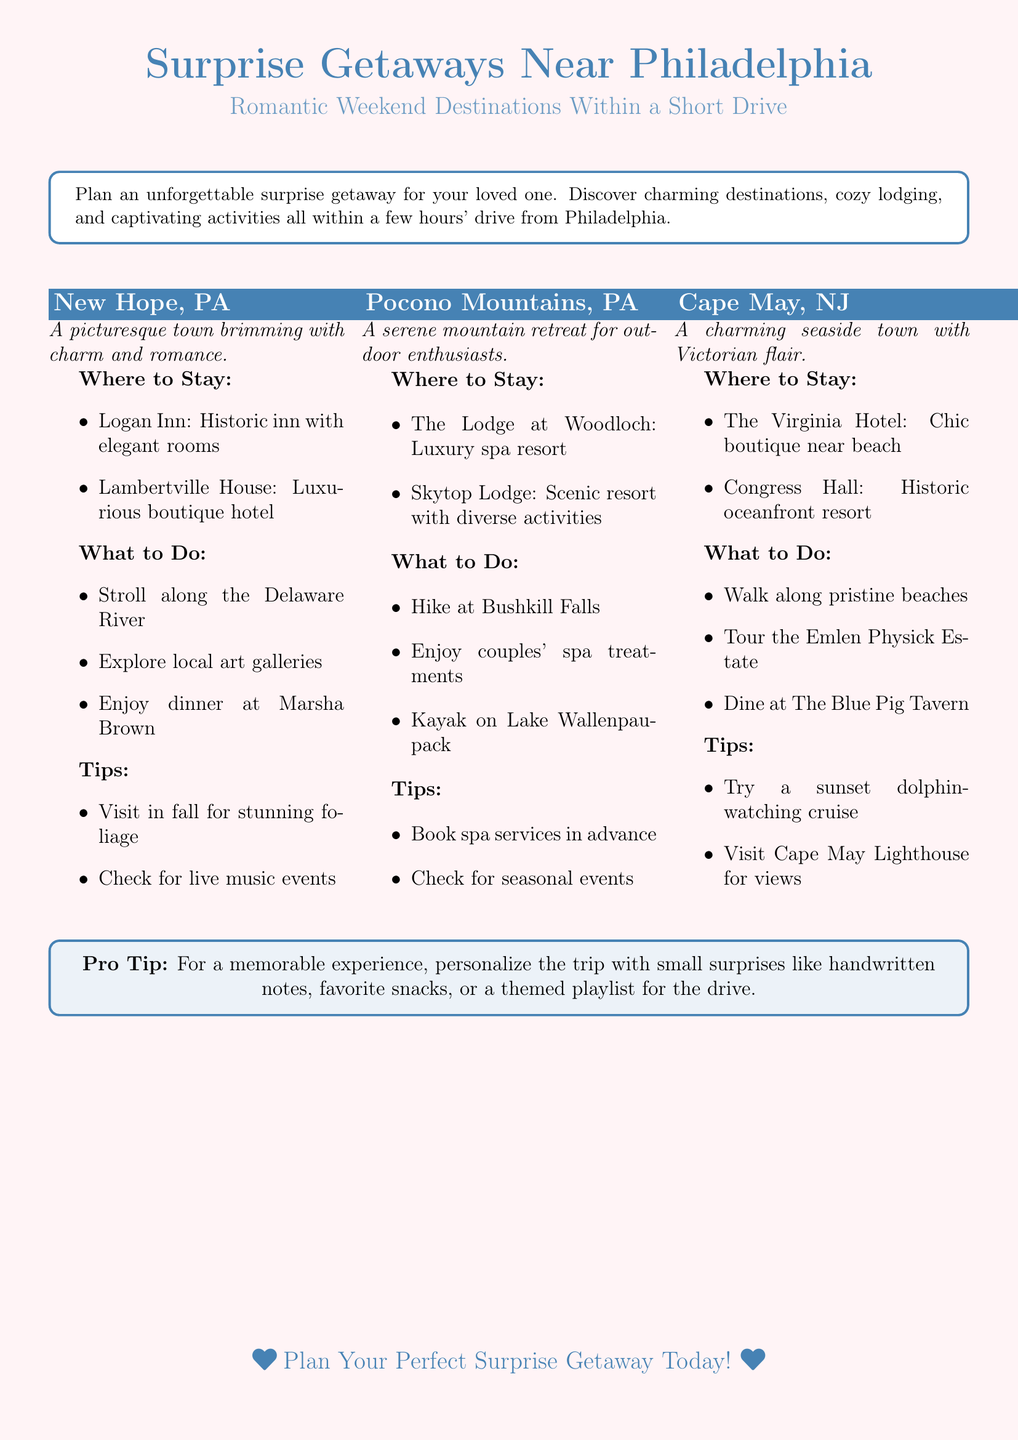What is the title of the flyer? The title is prominently displayed at the top of the document and states the main theme of the flyer.
Answer: Surprise Getaways Near Philadelphia How many getaway destinations are mentioned in the flyer? The flyer lists three specific getaway destinations, making it easy to plan a trip.
Answer: 3 What is one activity to do in New Hope, PA? The flyer lists several activities for each location, specifying what can be enjoyed at the respective destination.
Answer: Stroll along the Delaware River What is the recommended lodging in Cape May, NJ? Each getaway destination includes suggested lodging options for visitors looking for accommodation.
Answer: The Virginia Hotel What is a tip for visiting the Pocono Mountains? Tips are provided for enhancing the getaway experience at each destination.
Answer: Book spa services in advance Which nearby state is mentioned for a getaway? The flyer indicates locations in neighboring states, giving a broader range of travel options.
Answer: New Jersey What type of document is this? The format and layout suggest this document is intended to provide specific trip planning advice.
Answer: Flyer What is the color scheme used in the flyer? The design elements such as color and tone are described to enhance visual appeal and thematic relevance.
Answer: Romantic and accent colors 